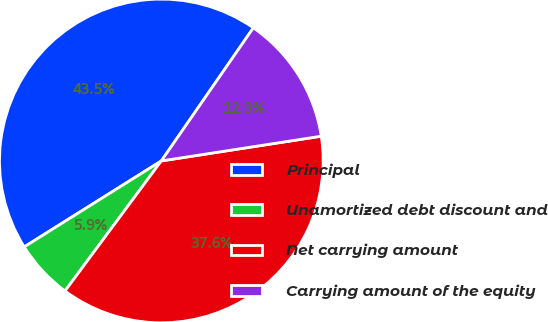Convert chart. <chart><loc_0><loc_0><loc_500><loc_500><pie_chart><fcel>Principal<fcel>Unamortized debt discount and<fcel>Net carrying amount<fcel>Carrying amount of the equity<nl><fcel>43.54%<fcel>5.94%<fcel>37.59%<fcel>12.93%<nl></chart> 